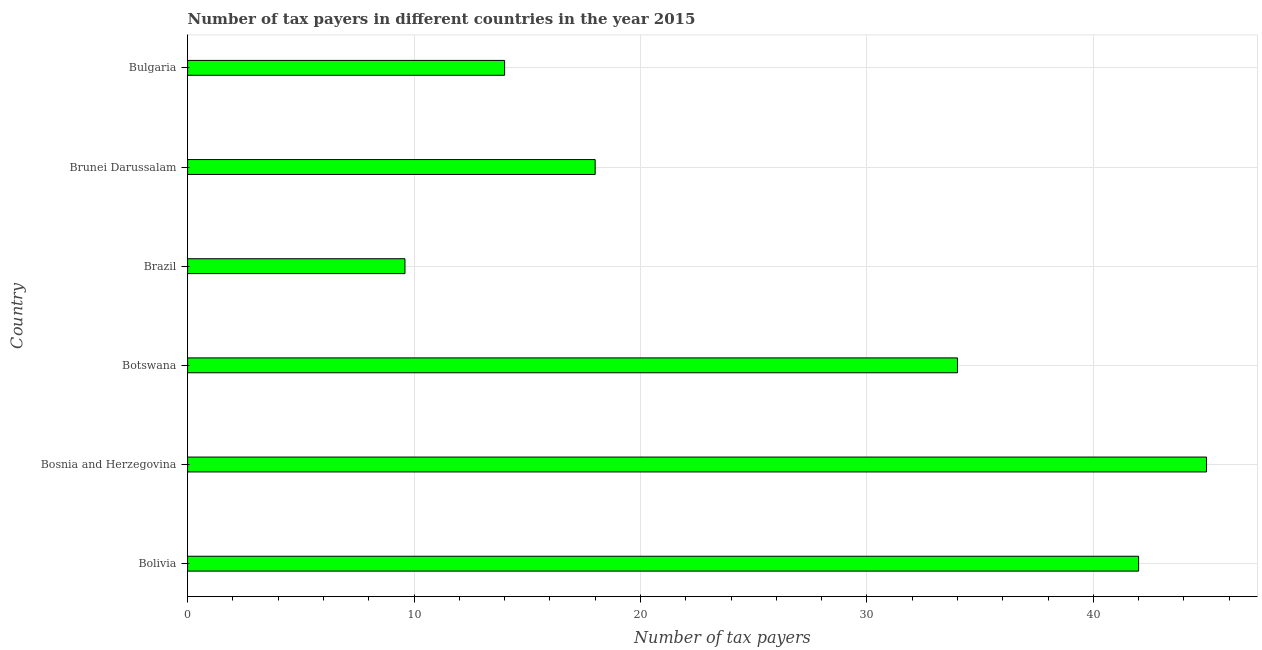Does the graph contain any zero values?
Provide a succinct answer. No. Does the graph contain grids?
Your answer should be compact. Yes. What is the title of the graph?
Ensure brevity in your answer.  Number of tax payers in different countries in the year 2015. What is the label or title of the X-axis?
Your answer should be compact. Number of tax payers. What is the number of tax payers in Brazil?
Offer a terse response. 9.6. Across all countries, what is the maximum number of tax payers?
Ensure brevity in your answer.  45. In which country was the number of tax payers maximum?
Your answer should be compact. Bosnia and Herzegovina. In which country was the number of tax payers minimum?
Ensure brevity in your answer.  Brazil. What is the sum of the number of tax payers?
Your answer should be very brief. 162.6. What is the difference between the number of tax payers in Bosnia and Herzegovina and Brunei Darussalam?
Provide a short and direct response. 27. What is the average number of tax payers per country?
Your response must be concise. 27.1. What is the ratio of the number of tax payers in Bosnia and Herzegovina to that in Brunei Darussalam?
Your response must be concise. 2.5. Is the number of tax payers in Bosnia and Herzegovina less than that in Bulgaria?
Ensure brevity in your answer.  No. What is the difference between the highest and the lowest number of tax payers?
Ensure brevity in your answer.  35.4. How many bars are there?
Provide a succinct answer. 6. Are the values on the major ticks of X-axis written in scientific E-notation?
Give a very brief answer. No. What is the Number of tax payers of Bolivia?
Offer a terse response. 42. What is the Number of tax payers of Bosnia and Herzegovina?
Your answer should be compact. 45. What is the Number of tax payers of Botswana?
Keep it short and to the point. 34. What is the Number of tax payers in Brazil?
Your response must be concise. 9.6. What is the difference between the Number of tax payers in Bolivia and Bosnia and Herzegovina?
Give a very brief answer. -3. What is the difference between the Number of tax payers in Bolivia and Brazil?
Your answer should be compact. 32.4. What is the difference between the Number of tax payers in Bolivia and Bulgaria?
Offer a very short reply. 28. What is the difference between the Number of tax payers in Bosnia and Herzegovina and Botswana?
Keep it short and to the point. 11. What is the difference between the Number of tax payers in Bosnia and Herzegovina and Brazil?
Offer a very short reply. 35.4. What is the difference between the Number of tax payers in Bosnia and Herzegovina and Bulgaria?
Give a very brief answer. 31. What is the difference between the Number of tax payers in Botswana and Brazil?
Your answer should be compact. 24.4. What is the difference between the Number of tax payers in Brazil and Bulgaria?
Give a very brief answer. -4.4. What is the ratio of the Number of tax payers in Bolivia to that in Bosnia and Herzegovina?
Keep it short and to the point. 0.93. What is the ratio of the Number of tax payers in Bolivia to that in Botswana?
Provide a short and direct response. 1.24. What is the ratio of the Number of tax payers in Bolivia to that in Brazil?
Your answer should be very brief. 4.38. What is the ratio of the Number of tax payers in Bolivia to that in Brunei Darussalam?
Offer a very short reply. 2.33. What is the ratio of the Number of tax payers in Bosnia and Herzegovina to that in Botswana?
Provide a succinct answer. 1.32. What is the ratio of the Number of tax payers in Bosnia and Herzegovina to that in Brazil?
Offer a terse response. 4.69. What is the ratio of the Number of tax payers in Bosnia and Herzegovina to that in Brunei Darussalam?
Give a very brief answer. 2.5. What is the ratio of the Number of tax payers in Bosnia and Herzegovina to that in Bulgaria?
Provide a short and direct response. 3.21. What is the ratio of the Number of tax payers in Botswana to that in Brazil?
Your answer should be compact. 3.54. What is the ratio of the Number of tax payers in Botswana to that in Brunei Darussalam?
Ensure brevity in your answer.  1.89. What is the ratio of the Number of tax payers in Botswana to that in Bulgaria?
Your answer should be very brief. 2.43. What is the ratio of the Number of tax payers in Brazil to that in Brunei Darussalam?
Give a very brief answer. 0.53. What is the ratio of the Number of tax payers in Brazil to that in Bulgaria?
Offer a terse response. 0.69. What is the ratio of the Number of tax payers in Brunei Darussalam to that in Bulgaria?
Your answer should be compact. 1.29. 